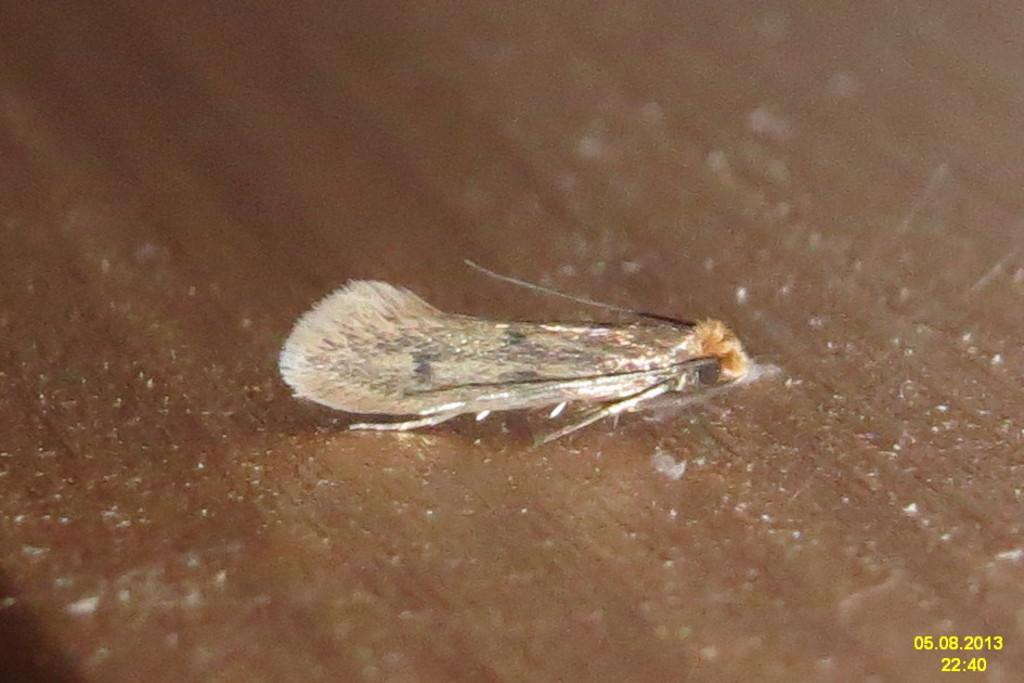What is present on the wooden surface in the image? There is an insect on a wooden surface in the image. Can you provide any additional information about the insect? Unfortunately, the image does not provide any further details about the insect. Where can the date and time be found in the image? The date and time are present in the bottom right corner of the image. What does the insect taste like in the image? There is no information about the taste of the insect in the image, as it is a visual representation and does not convey taste. 